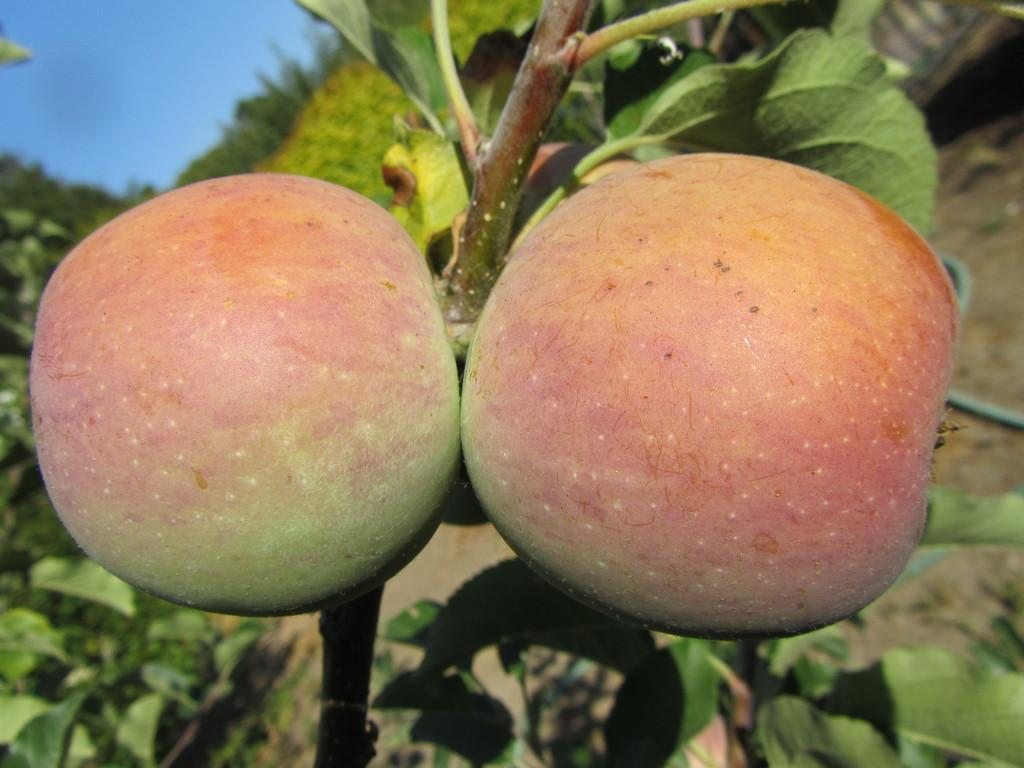How many apples are visible in the image? There are two apples in the image. What else can be seen in the image besides the apples? There are green leaves in the image. What type of paper is being used to provide shade in the image? There is no paper or shade present in the image, as it only features two apples and green leaves. 